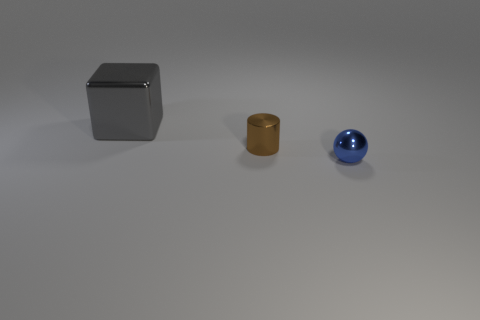Add 3 large yellow rubber balls. How many objects exist? 6 Subtract all cubes. How many objects are left? 2 Add 3 blue things. How many blue things are left? 4 Add 1 small blue shiny things. How many small blue shiny things exist? 2 Subtract 0 brown spheres. How many objects are left? 3 Subtract all shiny objects. Subtract all large green cylinders. How many objects are left? 0 